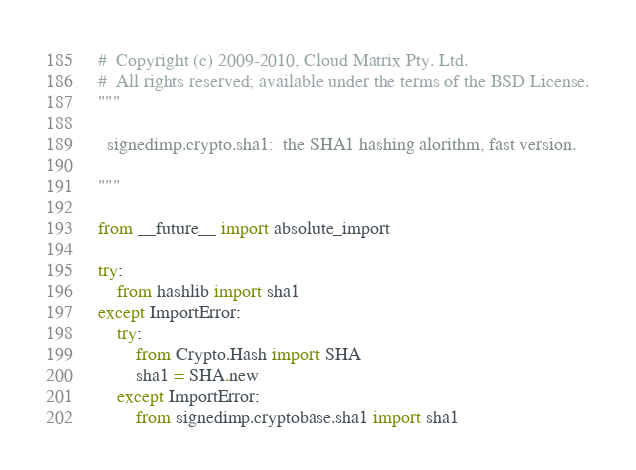<code> <loc_0><loc_0><loc_500><loc_500><_Python_>#  Copyright (c) 2009-2010, Cloud Matrix Pty. Ltd.
#  All rights reserved; available under the terms of the BSD License.
"""

  signedimp.crypto.sha1:  the SHA1 hashing alorithm, fast version.

"""

from __future__ import absolute_import

try:
    from hashlib import sha1
except ImportError:
    try:
        from Crypto.Hash import SHA
        sha1 = SHA.new
    except ImportError:
        from signedimp.cryptobase.sha1 import sha1


</code> 